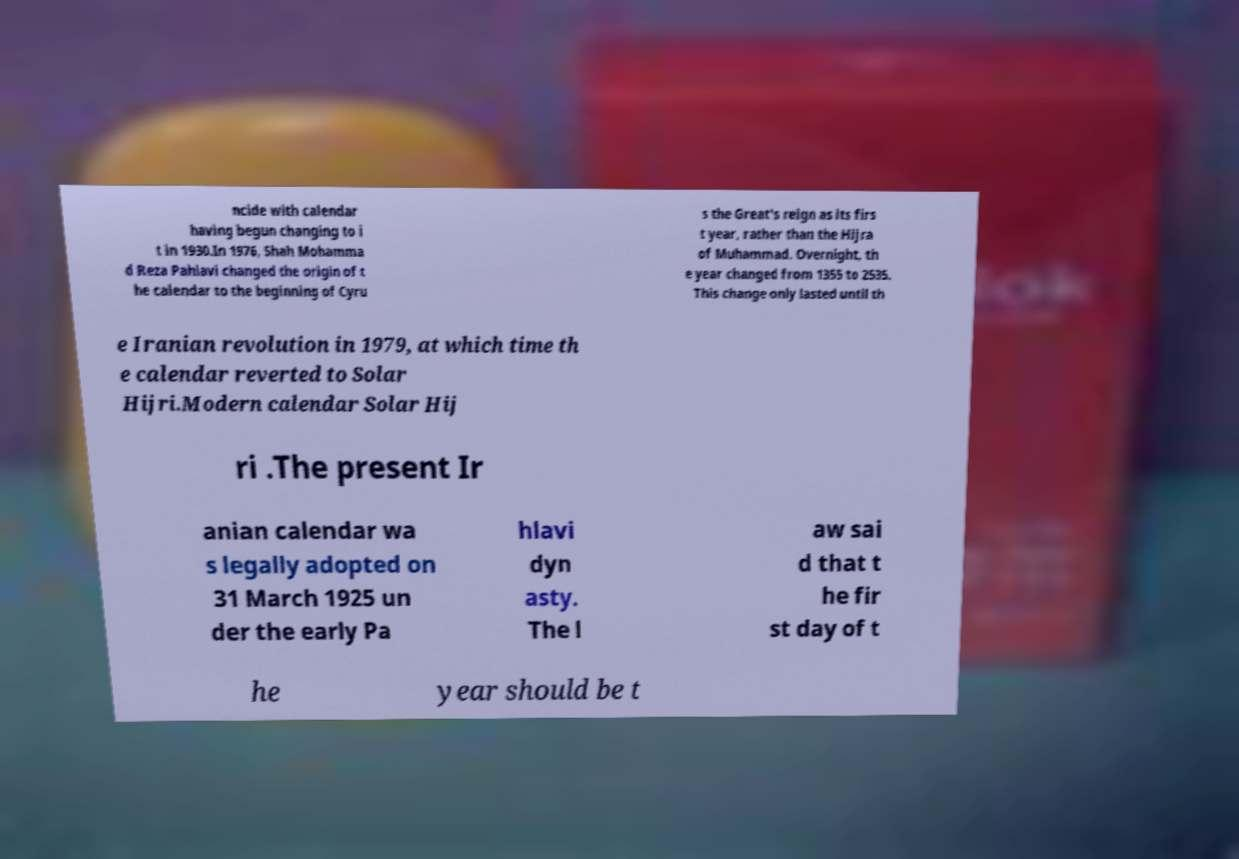Can you accurately transcribe the text from the provided image for me? ncide with calendar having begun changing to i t in 1930.In 1976, Shah Mohamma d Reza Pahlavi changed the origin of t he calendar to the beginning of Cyru s the Great's reign as its firs t year, rather than the Hijra of Muhammad. Overnight, th e year changed from 1355 to 2535. This change only lasted until th e Iranian revolution in 1979, at which time th e calendar reverted to Solar Hijri.Modern calendar Solar Hij ri .The present Ir anian calendar wa s legally adopted on 31 March 1925 un der the early Pa hlavi dyn asty. The l aw sai d that t he fir st day of t he year should be t 